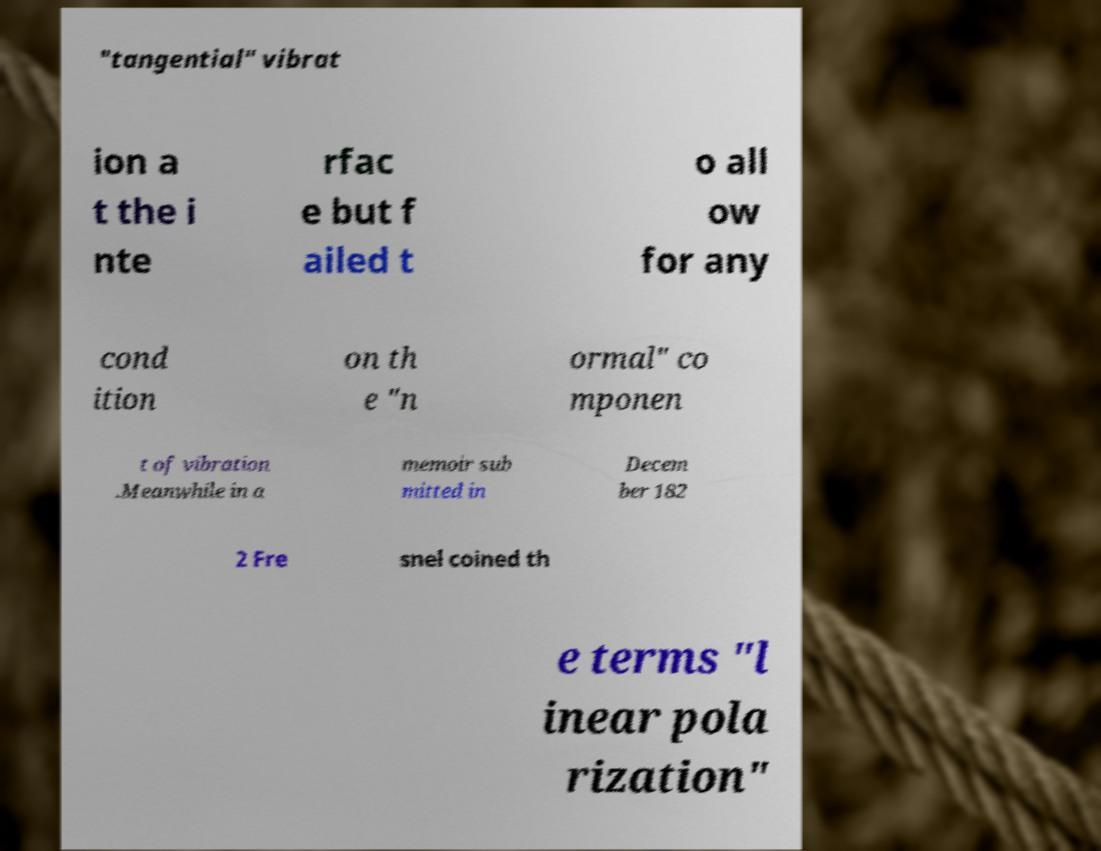Please identify and transcribe the text found in this image. "tangential" vibrat ion a t the i nte rfac e but f ailed t o all ow for any cond ition on th e "n ormal" co mponen t of vibration .Meanwhile in a memoir sub mitted in Decem ber 182 2 Fre snel coined th e terms "l inear pola rization" 